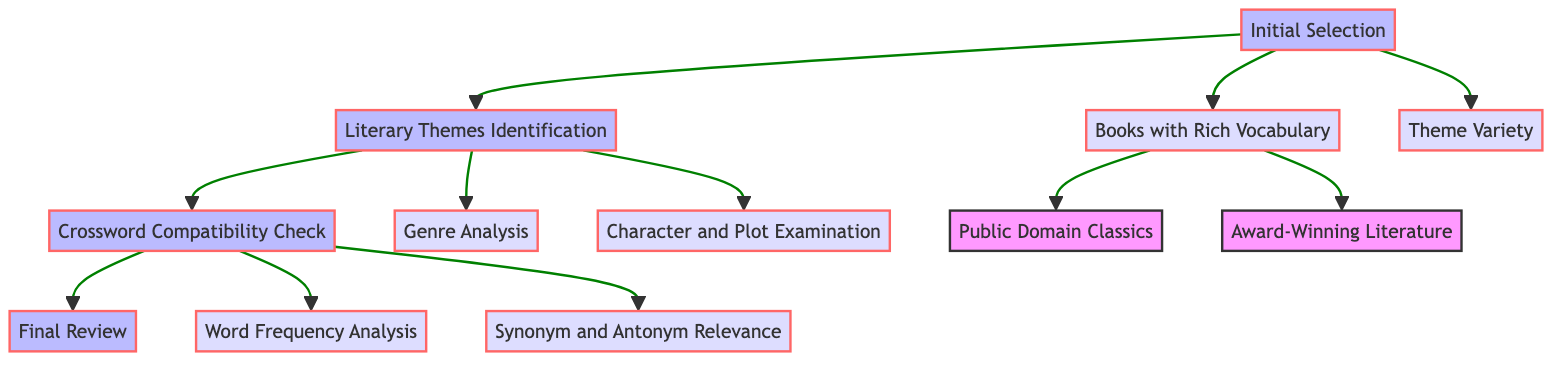What is the first step in evaluating classic books? The diagram indicates that the first step is "Initial Selection," which is the node at the bottom of the flow chart. It serves as the starting point in the overall evaluation process for classic books.
Answer: Initial Selection How many main functions are represented in the diagram? By counting the main functions in the flow chart, we find there are four: Initial Selection, Literary Themes Identification, Crossword Compatibility Check, and Final Review.
Answer: 4 What is examined in the "Character and Plot Examination"? According to the diagram, "Character and Plot Examination" involves analyzing characters and plotlines for central themes and motifs, identifying deeper thematic elements within the selected books.
Answer: Themes and motifs Which subfunction comes directly after "Literary Themes Identification"? The next subfunction directly after "Literary Themes Identification" is "Crossword Compatibility Check," as indicated by the flow connecting the two nodes upward in the chart.
Answer: Crossword Compatibility Check What are the two types of books selected in "Books with Rich Vocabulary"? The diagram shows two selections under "Books with Rich Vocabulary": "Public Domain Classics" and "Award-Winning Literature," indicating the criteria used for initial book selection.
Answer: Public Domain Classics and Award-Winning Literature Which two analyses are performed under "Crossword Compatibility Check"? The subfunctions under "Crossword Compatibility Check" are "Word Frequency Analysis" and "Synonym and Antonym Relevance." These analyses are vital to ensure thematic compatibility with crossword puzzles.
Answer: Word Frequency Analysis and Synonym and Antonym Relevance What is the final step in the evaluation process? The last function depicted in the flow chart is "Final Review," signifying that this is the concluding phase of the evaluation process after all previous steps have been completed.
Answer: Final Review What relationship exists between "Initial Selection" and "Theme Variety"? "Theme Variety" is a subfunction that branches directly from "Initial Selection," indicating it is part of the criteria for selecting classic books based on their thematic diversity.
Answer: Subfunction relationship How does "Genre Analysis" contribute to evaluating themes? "Genre Analysis" helps categorize the book under specific genres, which can offer insights into thematic elements and guide the suitability for crossword themes, thus playing a crucial role in identifying themes.
Answer: Categorizes by genres 